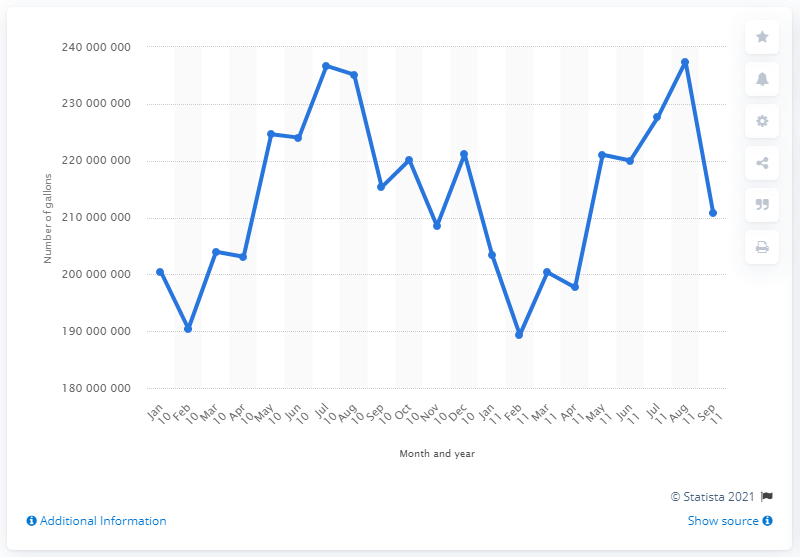Draw attention to some important aspects in this diagram. In January 2010, a total of 200,366,753 gallons of gasoline were sold in the state of Minnesota. In January 2011, a total of 203,357,828 gallons of gasoline were sold. 